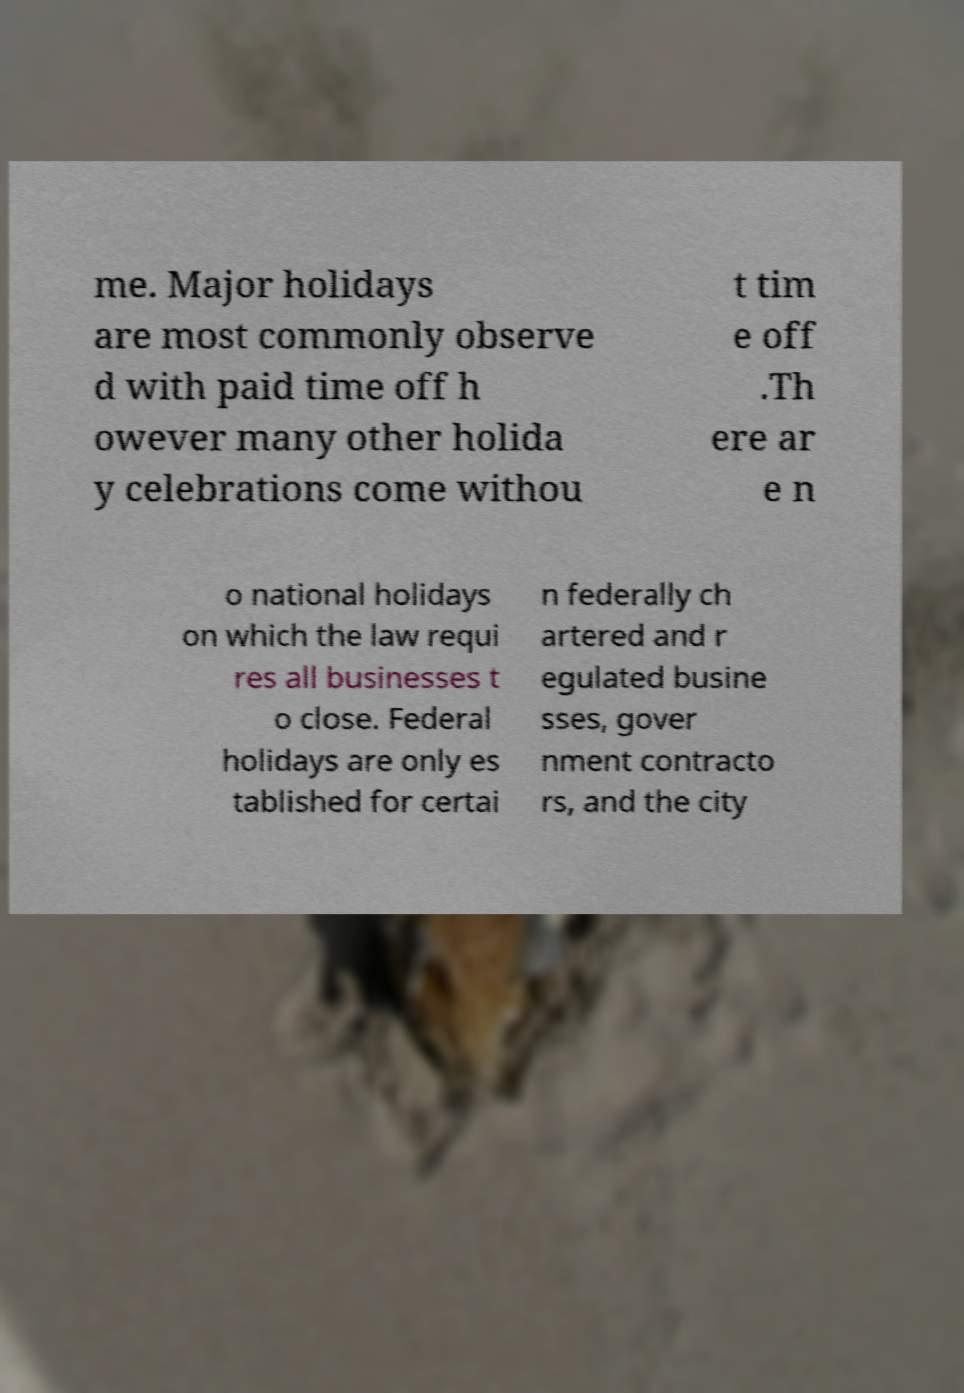Could you assist in decoding the text presented in this image and type it out clearly? me. Major holidays are most commonly observe d with paid time off h owever many other holida y celebrations come withou t tim e off .Th ere ar e n o national holidays on which the law requi res all businesses t o close. Federal holidays are only es tablished for certai n federally ch artered and r egulated busine sses, gover nment contracto rs, and the city 